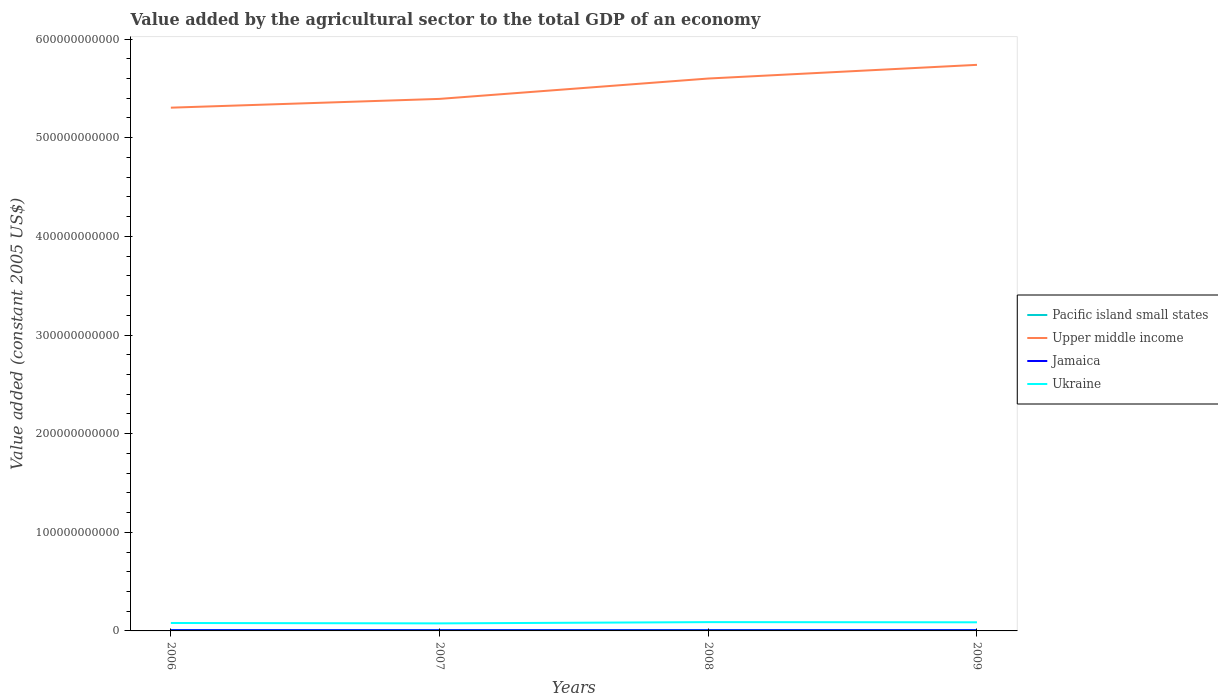Does the line corresponding to Jamaica intersect with the line corresponding to Ukraine?
Your answer should be very brief. No. Across all years, what is the maximum value added by the agricultural sector in Jamaica?
Your answer should be very brief. 6.01e+08. In which year was the value added by the agricultural sector in Ukraine maximum?
Your response must be concise. 2007. What is the total value added by the agricultural sector in Pacific island small states in the graph?
Give a very brief answer. 5.12e+07. What is the difference between the highest and the second highest value added by the agricultural sector in Jamaica?
Your response must be concise. 9.60e+07. Is the value added by the agricultural sector in Pacific island small states strictly greater than the value added by the agricultural sector in Upper middle income over the years?
Ensure brevity in your answer.  Yes. How many lines are there?
Ensure brevity in your answer.  4. How many years are there in the graph?
Your response must be concise. 4. What is the difference between two consecutive major ticks on the Y-axis?
Ensure brevity in your answer.  1.00e+11. Does the graph contain any zero values?
Provide a succinct answer. No. How are the legend labels stacked?
Offer a very short reply. Vertical. What is the title of the graph?
Keep it short and to the point. Value added by the agricultural sector to the total GDP of an economy. What is the label or title of the Y-axis?
Ensure brevity in your answer.  Value added (constant 2005 US$). What is the Value added (constant 2005 US$) of Pacific island small states in 2006?
Make the answer very short. 8.21e+08. What is the Value added (constant 2005 US$) of Upper middle income in 2006?
Ensure brevity in your answer.  5.30e+11. What is the Value added (constant 2005 US$) of Jamaica in 2006?
Provide a short and direct response. 6.97e+08. What is the Value added (constant 2005 US$) of Ukraine in 2006?
Give a very brief answer. 8.05e+09. What is the Value added (constant 2005 US$) in Pacific island small states in 2007?
Offer a very short reply. 8.13e+08. What is the Value added (constant 2005 US$) in Upper middle income in 2007?
Make the answer very short. 5.39e+11. What is the Value added (constant 2005 US$) in Jamaica in 2007?
Keep it short and to the point. 6.41e+08. What is the Value added (constant 2005 US$) in Ukraine in 2007?
Your response must be concise. 7.65e+09. What is the Value added (constant 2005 US$) in Pacific island small states in 2008?
Keep it short and to the point. 8.07e+08. What is the Value added (constant 2005 US$) of Upper middle income in 2008?
Your answer should be compact. 5.60e+11. What is the Value added (constant 2005 US$) in Jamaica in 2008?
Provide a short and direct response. 6.01e+08. What is the Value added (constant 2005 US$) in Ukraine in 2008?
Ensure brevity in your answer.  8.91e+09. What is the Value added (constant 2005 US$) of Pacific island small states in 2009?
Your answer should be compact. 7.62e+08. What is the Value added (constant 2005 US$) of Upper middle income in 2009?
Your answer should be compact. 5.74e+11. What is the Value added (constant 2005 US$) of Jamaica in 2009?
Your response must be concise. 6.85e+08. What is the Value added (constant 2005 US$) in Ukraine in 2009?
Keep it short and to the point. 8.74e+09. Across all years, what is the maximum Value added (constant 2005 US$) of Pacific island small states?
Make the answer very short. 8.21e+08. Across all years, what is the maximum Value added (constant 2005 US$) of Upper middle income?
Your response must be concise. 5.74e+11. Across all years, what is the maximum Value added (constant 2005 US$) in Jamaica?
Keep it short and to the point. 6.97e+08. Across all years, what is the maximum Value added (constant 2005 US$) of Ukraine?
Keep it short and to the point. 8.91e+09. Across all years, what is the minimum Value added (constant 2005 US$) in Pacific island small states?
Offer a terse response. 7.62e+08. Across all years, what is the minimum Value added (constant 2005 US$) of Upper middle income?
Offer a terse response. 5.30e+11. Across all years, what is the minimum Value added (constant 2005 US$) of Jamaica?
Keep it short and to the point. 6.01e+08. Across all years, what is the minimum Value added (constant 2005 US$) in Ukraine?
Your response must be concise. 7.65e+09. What is the total Value added (constant 2005 US$) of Pacific island small states in the graph?
Keep it short and to the point. 3.20e+09. What is the total Value added (constant 2005 US$) of Upper middle income in the graph?
Provide a succinct answer. 2.20e+12. What is the total Value added (constant 2005 US$) of Jamaica in the graph?
Give a very brief answer. 2.62e+09. What is the total Value added (constant 2005 US$) in Ukraine in the graph?
Give a very brief answer. 3.33e+1. What is the difference between the Value added (constant 2005 US$) in Pacific island small states in 2006 and that in 2007?
Your answer should be compact. 7.71e+06. What is the difference between the Value added (constant 2005 US$) in Upper middle income in 2006 and that in 2007?
Your answer should be compact. -8.90e+09. What is the difference between the Value added (constant 2005 US$) of Jamaica in 2006 and that in 2007?
Ensure brevity in your answer.  5.65e+07. What is the difference between the Value added (constant 2005 US$) of Ukraine in 2006 and that in 2007?
Offer a terse response. 4.02e+08. What is the difference between the Value added (constant 2005 US$) in Pacific island small states in 2006 and that in 2008?
Make the answer very short. 1.34e+07. What is the difference between the Value added (constant 2005 US$) in Upper middle income in 2006 and that in 2008?
Offer a very short reply. -2.95e+1. What is the difference between the Value added (constant 2005 US$) of Jamaica in 2006 and that in 2008?
Offer a terse response. 9.60e+07. What is the difference between the Value added (constant 2005 US$) of Ukraine in 2006 and that in 2008?
Give a very brief answer. -8.67e+08. What is the difference between the Value added (constant 2005 US$) in Pacific island small states in 2006 and that in 2009?
Provide a succinct answer. 5.89e+07. What is the difference between the Value added (constant 2005 US$) of Upper middle income in 2006 and that in 2009?
Keep it short and to the point. -4.34e+1. What is the difference between the Value added (constant 2005 US$) of Jamaica in 2006 and that in 2009?
Give a very brief answer. 1.20e+07. What is the difference between the Value added (constant 2005 US$) in Ukraine in 2006 and that in 2009?
Give a very brief answer. -6.88e+08. What is the difference between the Value added (constant 2005 US$) in Pacific island small states in 2007 and that in 2008?
Provide a succinct answer. 5.72e+06. What is the difference between the Value added (constant 2005 US$) in Upper middle income in 2007 and that in 2008?
Make the answer very short. -2.06e+1. What is the difference between the Value added (constant 2005 US$) in Jamaica in 2007 and that in 2008?
Offer a terse response. 3.95e+07. What is the difference between the Value added (constant 2005 US$) of Ukraine in 2007 and that in 2008?
Give a very brief answer. -1.27e+09. What is the difference between the Value added (constant 2005 US$) in Pacific island small states in 2007 and that in 2009?
Ensure brevity in your answer.  5.12e+07. What is the difference between the Value added (constant 2005 US$) in Upper middle income in 2007 and that in 2009?
Your answer should be very brief. -3.45e+1. What is the difference between the Value added (constant 2005 US$) in Jamaica in 2007 and that in 2009?
Keep it short and to the point. -4.45e+07. What is the difference between the Value added (constant 2005 US$) of Ukraine in 2007 and that in 2009?
Ensure brevity in your answer.  -1.09e+09. What is the difference between the Value added (constant 2005 US$) in Pacific island small states in 2008 and that in 2009?
Your answer should be compact. 4.54e+07. What is the difference between the Value added (constant 2005 US$) in Upper middle income in 2008 and that in 2009?
Keep it short and to the point. -1.39e+1. What is the difference between the Value added (constant 2005 US$) of Jamaica in 2008 and that in 2009?
Provide a succinct answer. -8.40e+07. What is the difference between the Value added (constant 2005 US$) of Ukraine in 2008 and that in 2009?
Offer a terse response. 1.78e+08. What is the difference between the Value added (constant 2005 US$) of Pacific island small states in 2006 and the Value added (constant 2005 US$) of Upper middle income in 2007?
Offer a terse response. -5.39e+11. What is the difference between the Value added (constant 2005 US$) of Pacific island small states in 2006 and the Value added (constant 2005 US$) of Jamaica in 2007?
Your response must be concise. 1.80e+08. What is the difference between the Value added (constant 2005 US$) in Pacific island small states in 2006 and the Value added (constant 2005 US$) in Ukraine in 2007?
Keep it short and to the point. -6.82e+09. What is the difference between the Value added (constant 2005 US$) of Upper middle income in 2006 and the Value added (constant 2005 US$) of Jamaica in 2007?
Your answer should be very brief. 5.30e+11. What is the difference between the Value added (constant 2005 US$) in Upper middle income in 2006 and the Value added (constant 2005 US$) in Ukraine in 2007?
Provide a short and direct response. 5.23e+11. What is the difference between the Value added (constant 2005 US$) in Jamaica in 2006 and the Value added (constant 2005 US$) in Ukraine in 2007?
Make the answer very short. -6.95e+09. What is the difference between the Value added (constant 2005 US$) in Pacific island small states in 2006 and the Value added (constant 2005 US$) in Upper middle income in 2008?
Provide a short and direct response. -5.59e+11. What is the difference between the Value added (constant 2005 US$) in Pacific island small states in 2006 and the Value added (constant 2005 US$) in Jamaica in 2008?
Provide a short and direct response. 2.20e+08. What is the difference between the Value added (constant 2005 US$) of Pacific island small states in 2006 and the Value added (constant 2005 US$) of Ukraine in 2008?
Give a very brief answer. -8.09e+09. What is the difference between the Value added (constant 2005 US$) of Upper middle income in 2006 and the Value added (constant 2005 US$) of Jamaica in 2008?
Give a very brief answer. 5.30e+11. What is the difference between the Value added (constant 2005 US$) of Upper middle income in 2006 and the Value added (constant 2005 US$) of Ukraine in 2008?
Provide a short and direct response. 5.22e+11. What is the difference between the Value added (constant 2005 US$) in Jamaica in 2006 and the Value added (constant 2005 US$) in Ukraine in 2008?
Give a very brief answer. -8.22e+09. What is the difference between the Value added (constant 2005 US$) in Pacific island small states in 2006 and the Value added (constant 2005 US$) in Upper middle income in 2009?
Your answer should be very brief. -5.73e+11. What is the difference between the Value added (constant 2005 US$) of Pacific island small states in 2006 and the Value added (constant 2005 US$) of Jamaica in 2009?
Offer a terse response. 1.36e+08. What is the difference between the Value added (constant 2005 US$) in Pacific island small states in 2006 and the Value added (constant 2005 US$) in Ukraine in 2009?
Keep it short and to the point. -7.92e+09. What is the difference between the Value added (constant 2005 US$) of Upper middle income in 2006 and the Value added (constant 2005 US$) of Jamaica in 2009?
Provide a succinct answer. 5.30e+11. What is the difference between the Value added (constant 2005 US$) of Upper middle income in 2006 and the Value added (constant 2005 US$) of Ukraine in 2009?
Offer a very short reply. 5.22e+11. What is the difference between the Value added (constant 2005 US$) of Jamaica in 2006 and the Value added (constant 2005 US$) of Ukraine in 2009?
Provide a succinct answer. -8.04e+09. What is the difference between the Value added (constant 2005 US$) of Pacific island small states in 2007 and the Value added (constant 2005 US$) of Upper middle income in 2008?
Provide a succinct answer. -5.59e+11. What is the difference between the Value added (constant 2005 US$) of Pacific island small states in 2007 and the Value added (constant 2005 US$) of Jamaica in 2008?
Offer a very short reply. 2.12e+08. What is the difference between the Value added (constant 2005 US$) in Pacific island small states in 2007 and the Value added (constant 2005 US$) in Ukraine in 2008?
Ensure brevity in your answer.  -8.10e+09. What is the difference between the Value added (constant 2005 US$) in Upper middle income in 2007 and the Value added (constant 2005 US$) in Jamaica in 2008?
Provide a short and direct response. 5.39e+11. What is the difference between the Value added (constant 2005 US$) of Upper middle income in 2007 and the Value added (constant 2005 US$) of Ukraine in 2008?
Keep it short and to the point. 5.30e+11. What is the difference between the Value added (constant 2005 US$) in Jamaica in 2007 and the Value added (constant 2005 US$) in Ukraine in 2008?
Keep it short and to the point. -8.27e+09. What is the difference between the Value added (constant 2005 US$) in Pacific island small states in 2007 and the Value added (constant 2005 US$) in Upper middle income in 2009?
Keep it short and to the point. -5.73e+11. What is the difference between the Value added (constant 2005 US$) of Pacific island small states in 2007 and the Value added (constant 2005 US$) of Jamaica in 2009?
Provide a succinct answer. 1.28e+08. What is the difference between the Value added (constant 2005 US$) of Pacific island small states in 2007 and the Value added (constant 2005 US$) of Ukraine in 2009?
Provide a succinct answer. -7.92e+09. What is the difference between the Value added (constant 2005 US$) of Upper middle income in 2007 and the Value added (constant 2005 US$) of Jamaica in 2009?
Your answer should be compact. 5.39e+11. What is the difference between the Value added (constant 2005 US$) in Upper middle income in 2007 and the Value added (constant 2005 US$) in Ukraine in 2009?
Offer a very short reply. 5.31e+11. What is the difference between the Value added (constant 2005 US$) in Jamaica in 2007 and the Value added (constant 2005 US$) in Ukraine in 2009?
Your answer should be very brief. -8.10e+09. What is the difference between the Value added (constant 2005 US$) in Pacific island small states in 2008 and the Value added (constant 2005 US$) in Upper middle income in 2009?
Provide a succinct answer. -5.73e+11. What is the difference between the Value added (constant 2005 US$) in Pacific island small states in 2008 and the Value added (constant 2005 US$) in Jamaica in 2009?
Provide a short and direct response. 1.22e+08. What is the difference between the Value added (constant 2005 US$) of Pacific island small states in 2008 and the Value added (constant 2005 US$) of Ukraine in 2009?
Make the answer very short. -7.93e+09. What is the difference between the Value added (constant 2005 US$) of Upper middle income in 2008 and the Value added (constant 2005 US$) of Jamaica in 2009?
Ensure brevity in your answer.  5.59e+11. What is the difference between the Value added (constant 2005 US$) in Upper middle income in 2008 and the Value added (constant 2005 US$) in Ukraine in 2009?
Ensure brevity in your answer.  5.51e+11. What is the difference between the Value added (constant 2005 US$) in Jamaica in 2008 and the Value added (constant 2005 US$) in Ukraine in 2009?
Your answer should be compact. -8.13e+09. What is the average Value added (constant 2005 US$) of Pacific island small states per year?
Your answer should be compact. 8.01e+08. What is the average Value added (constant 2005 US$) of Upper middle income per year?
Provide a succinct answer. 5.51e+11. What is the average Value added (constant 2005 US$) of Jamaica per year?
Ensure brevity in your answer.  6.56e+08. What is the average Value added (constant 2005 US$) in Ukraine per year?
Ensure brevity in your answer.  8.34e+09. In the year 2006, what is the difference between the Value added (constant 2005 US$) of Pacific island small states and Value added (constant 2005 US$) of Upper middle income?
Ensure brevity in your answer.  -5.30e+11. In the year 2006, what is the difference between the Value added (constant 2005 US$) of Pacific island small states and Value added (constant 2005 US$) of Jamaica?
Provide a short and direct response. 1.24e+08. In the year 2006, what is the difference between the Value added (constant 2005 US$) of Pacific island small states and Value added (constant 2005 US$) of Ukraine?
Offer a terse response. -7.23e+09. In the year 2006, what is the difference between the Value added (constant 2005 US$) of Upper middle income and Value added (constant 2005 US$) of Jamaica?
Provide a short and direct response. 5.30e+11. In the year 2006, what is the difference between the Value added (constant 2005 US$) in Upper middle income and Value added (constant 2005 US$) in Ukraine?
Offer a terse response. 5.22e+11. In the year 2006, what is the difference between the Value added (constant 2005 US$) of Jamaica and Value added (constant 2005 US$) of Ukraine?
Keep it short and to the point. -7.35e+09. In the year 2007, what is the difference between the Value added (constant 2005 US$) in Pacific island small states and Value added (constant 2005 US$) in Upper middle income?
Ensure brevity in your answer.  -5.39e+11. In the year 2007, what is the difference between the Value added (constant 2005 US$) in Pacific island small states and Value added (constant 2005 US$) in Jamaica?
Your answer should be very brief. 1.73e+08. In the year 2007, what is the difference between the Value added (constant 2005 US$) of Pacific island small states and Value added (constant 2005 US$) of Ukraine?
Offer a terse response. -6.83e+09. In the year 2007, what is the difference between the Value added (constant 2005 US$) of Upper middle income and Value added (constant 2005 US$) of Jamaica?
Give a very brief answer. 5.39e+11. In the year 2007, what is the difference between the Value added (constant 2005 US$) in Upper middle income and Value added (constant 2005 US$) in Ukraine?
Make the answer very short. 5.32e+11. In the year 2007, what is the difference between the Value added (constant 2005 US$) of Jamaica and Value added (constant 2005 US$) of Ukraine?
Keep it short and to the point. -7.00e+09. In the year 2008, what is the difference between the Value added (constant 2005 US$) in Pacific island small states and Value added (constant 2005 US$) in Upper middle income?
Keep it short and to the point. -5.59e+11. In the year 2008, what is the difference between the Value added (constant 2005 US$) of Pacific island small states and Value added (constant 2005 US$) of Jamaica?
Offer a terse response. 2.06e+08. In the year 2008, what is the difference between the Value added (constant 2005 US$) in Pacific island small states and Value added (constant 2005 US$) in Ukraine?
Ensure brevity in your answer.  -8.11e+09. In the year 2008, what is the difference between the Value added (constant 2005 US$) of Upper middle income and Value added (constant 2005 US$) of Jamaica?
Provide a succinct answer. 5.59e+11. In the year 2008, what is the difference between the Value added (constant 2005 US$) in Upper middle income and Value added (constant 2005 US$) in Ukraine?
Provide a short and direct response. 5.51e+11. In the year 2008, what is the difference between the Value added (constant 2005 US$) in Jamaica and Value added (constant 2005 US$) in Ukraine?
Offer a terse response. -8.31e+09. In the year 2009, what is the difference between the Value added (constant 2005 US$) in Pacific island small states and Value added (constant 2005 US$) in Upper middle income?
Your response must be concise. -5.73e+11. In the year 2009, what is the difference between the Value added (constant 2005 US$) in Pacific island small states and Value added (constant 2005 US$) in Jamaica?
Keep it short and to the point. 7.68e+07. In the year 2009, what is the difference between the Value added (constant 2005 US$) of Pacific island small states and Value added (constant 2005 US$) of Ukraine?
Make the answer very short. -7.97e+09. In the year 2009, what is the difference between the Value added (constant 2005 US$) in Upper middle income and Value added (constant 2005 US$) in Jamaica?
Ensure brevity in your answer.  5.73e+11. In the year 2009, what is the difference between the Value added (constant 2005 US$) in Upper middle income and Value added (constant 2005 US$) in Ukraine?
Provide a short and direct response. 5.65e+11. In the year 2009, what is the difference between the Value added (constant 2005 US$) in Jamaica and Value added (constant 2005 US$) in Ukraine?
Your answer should be very brief. -8.05e+09. What is the ratio of the Value added (constant 2005 US$) of Pacific island small states in 2006 to that in 2007?
Your answer should be very brief. 1.01. What is the ratio of the Value added (constant 2005 US$) in Upper middle income in 2006 to that in 2007?
Provide a succinct answer. 0.98. What is the ratio of the Value added (constant 2005 US$) in Jamaica in 2006 to that in 2007?
Your response must be concise. 1.09. What is the ratio of the Value added (constant 2005 US$) in Ukraine in 2006 to that in 2007?
Your answer should be compact. 1.05. What is the ratio of the Value added (constant 2005 US$) of Pacific island small states in 2006 to that in 2008?
Ensure brevity in your answer.  1.02. What is the ratio of the Value added (constant 2005 US$) of Upper middle income in 2006 to that in 2008?
Your answer should be compact. 0.95. What is the ratio of the Value added (constant 2005 US$) of Jamaica in 2006 to that in 2008?
Provide a succinct answer. 1.16. What is the ratio of the Value added (constant 2005 US$) in Ukraine in 2006 to that in 2008?
Offer a very short reply. 0.9. What is the ratio of the Value added (constant 2005 US$) of Pacific island small states in 2006 to that in 2009?
Keep it short and to the point. 1.08. What is the ratio of the Value added (constant 2005 US$) of Upper middle income in 2006 to that in 2009?
Your answer should be very brief. 0.92. What is the ratio of the Value added (constant 2005 US$) of Jamaica in 2006 to that in 2009?
Keep it short and to the point. 1.02. What is the ratio of the Value added (constant 2005 US$) of Ukraine in 2006 to that in 2009?
Your response must be concise. 0.92. What is the ratio of the Value added (constant 2005 US$) of Pacific island small states in 2007 to that in 2008?
Your answer should be very brief. 1.01. What is the ratio of the Value added (constant 2005 US$) of Upper middle income in 2007 to that in 2008?
Keep it short and to the point. 0.96. What is the ratio of the Value added (constant 2005 US$) of Jamaica in 2007 to that in 2008?
Your response must be concise. 1.07. What is the ratio of the Value added (constant 2005 US$) of Ukraine in 2007 to that in 2008?
Keep it short and to the point. 0.86. What is the ratio of the Value added (constant 2005 US$) in Pacific island small states in 2007 to that in 2009?
Provide a succinct answer. 1.07. What is the ratio of the Value added (constant 2005 US$) of Upper middle income in 2007 to that in 2009?
Make the answer very short. 0.94. What is the ratio of the Value added (constant 2005 US$) of Jamaica in 2007 to that in 2009?
Provide a short and direct response. 0.94. What is the ratio of the Value added (constant 2005 US$) of Ukraine in 2007 to that in 2009?
Give a very brief answer. 0.88. What is the ratio of the Value added (constant 2005 US$) of Pacific island small states in 2008 to that in 2009?
Your answer should be very brief. 1.06. What is the ratio of the Value added (constant 2005 US$) of Upper middle income in 2008 to that in 2009?
Offer a very short reply. 0.98. What is the ratio of the Value added (constant 2005 US$) in Jamaica in 2008 to that in 2009?
Keep it short and to the point. 0.88. What is the ratio of the Value added (constant 2005 US$) of Ukraine in 2008 to that in 2009?
Your answer should be compact. 1.02. What is the difference between the highest and the second highest Value added (constant 2005 US$) in Pacific island small states?
Offer a very short reply. 7.71e+06. What is the difference between the highest and the second highest Value added (constant 2005 US$) of Upper middle income?
Provide a short and direct response. 1.39e+1. What is the difference between the highest and the second highest Value added (constant 2005 US$) in Jamaica?
Keep it short and to the point. 1.20e+07. What is the difference between the highest and the second highest Value added (constant 2005 US$) in Ukraine?
Your answer should be compact. 1.78e+08. What is the difference between the highest and the lowest Value added (constant 2005 US$) in Pacific island small states?
Provide a short and direct response. 5.89e+07. What is the difference between the highest and the lowest Value added (constant 2005 US$) in Upper middle income?
Your response must be concise. 4.34e+1. What is the difference between the highest and the lowest Value added (constant 2005 US$) in Jamaica?
Your answer should be compact. 9.60e+07. What is the difference between the highest and the lowest Value added (constant 2005 US$) in Ukraine?
Provide a short and direct response. 1.27e+09. 